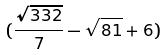<formula> <loc_0><loc_0><loc_500><loc_500>( \frac { \sqrt { 3 3 2 } } { 7 } - \sqrt { 8 1 } + 6 )</formula> 